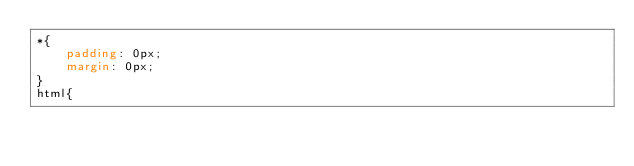<code> <loc_0><loc_0><loc_500><loc_500><_CSS_>*{
    padding: 0px;
    margin: 0px;
} 
html{</code> 